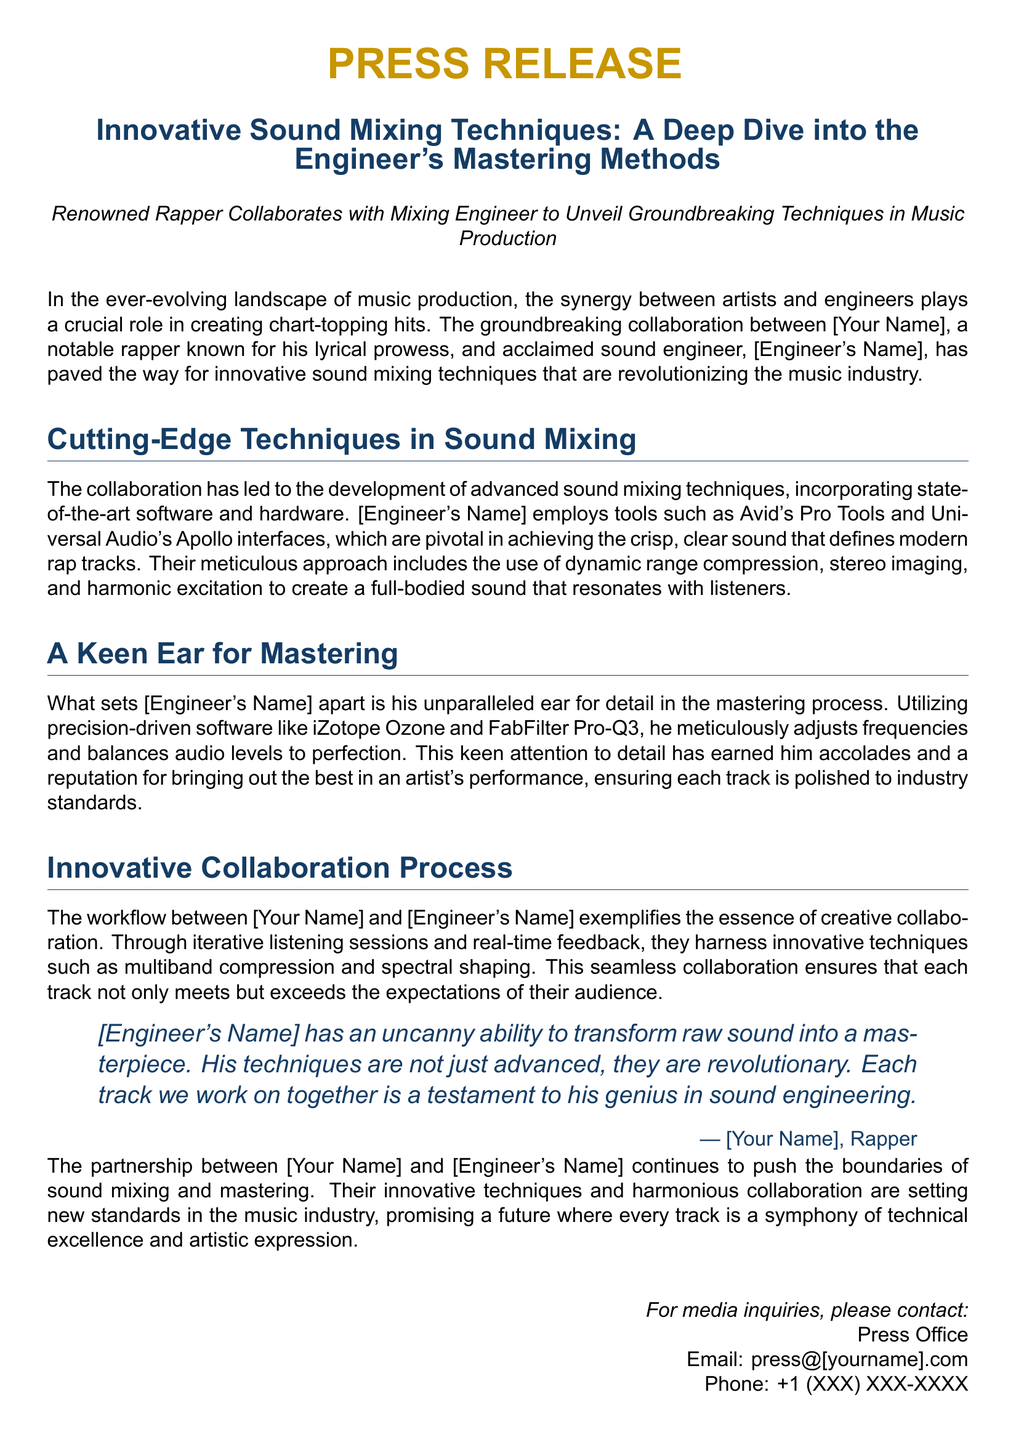What is the title of the press release? The title is explicitly stated in the document and reflects the content discussed.
Answer: Innovative Sound Mixing Techniques: A Deep Dive into the Engineer's Mastering Methods Who is the renowned rapper collaborating with the engineer? The rapper is mentioned in the opening paragraph as a notable figure known for his lyrical prowess.
Answer: [Your Name] What software does the engineer use for mastering? The document lists specific software utilized in the mastering process, highlighting the tools for sound adjustment.
Answer: iZotope Ozone What technique is emphasized for its role in achieving a full-bodied sound? This information is provided in the section discussing advanced sound mixing techniques, reflecting their approach to sound.
Answer: Dynamic range compression How does the collaboration process between the rapper and engineer exemplify creative synergy? This insight is inferred through the description of their iterative listening sessions and collaborative techniques mentioned.
Answer: Innovative techniques such as multiband compression What is the contact email for media inquiries? The email is explicitly stated for press inquiries in the contact section of the press release.
Answer: press@[yourname].com Which sound interface is mentioned as pivotal in the mixing process? The document highlights specific hardware as essential for achieving the desired sound clarity.
Answer: Universal Audio's Apollo interfaces What is the significance of the engineer's ear for detail? The document elaborates on the importance of this trait in relation to mastering quality and artist performance enhancement.
Answer: Unparalleled ear for detail How does the partnership aim to influence future music production? The conclusion discusses aspirations for evolving standards in the music industry through their collaboration.
Answer: Setting new standards in the music industry 